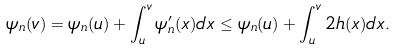Convert formula to latex. <formula><loc_0><loc_0><loc_500><loc_500>\psi _ { n } ( v ) = \psi _ { n } ( u ) + \int _ { u } ^ { v } \psi ^ { \prime } _ { n } ( x ) d x \leq \psi _ { n } ( u ) + \int _ { u } ^ { v } 2 h ( x ) d x .</formula> 